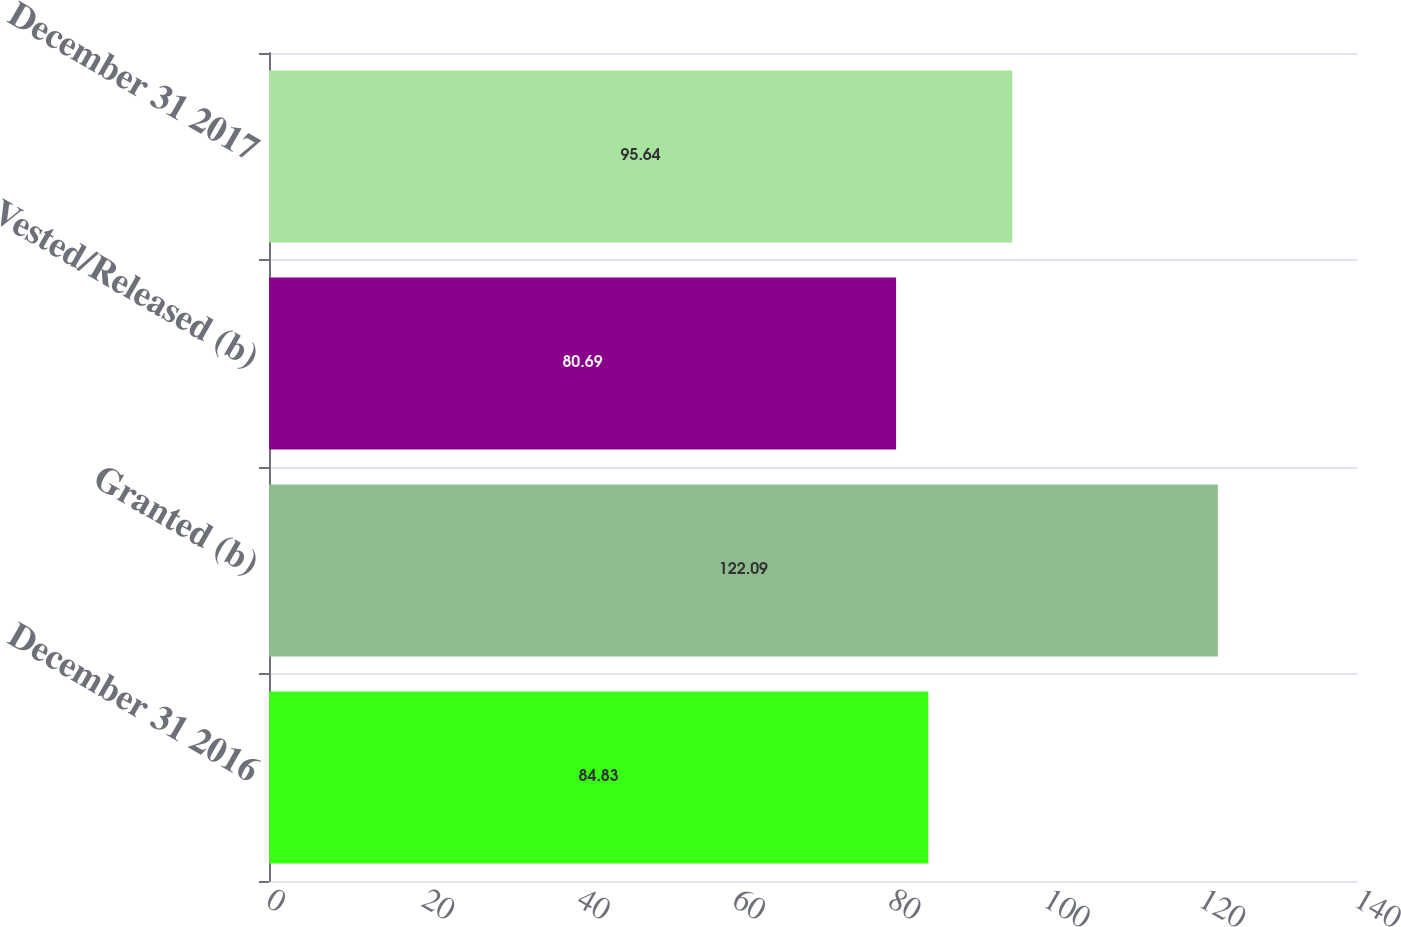Convert chart to OTSL. <chart><loc_0><loc_0><loc_500><loc_500><bar_chart><fcel>December 31 2016<fcel>Granted (b)<fcel>Vested/Released (b)<fcel>December 31 2017<nl><fcel>84.83<fcel>122.09<fcel>80.69<fcel>95.64<nl></chart> 